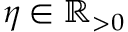<formula> <loc_0><loc_0><loc_500><loc_500>\eta \in \mathbb { R } _ { > 0 }</formula> 